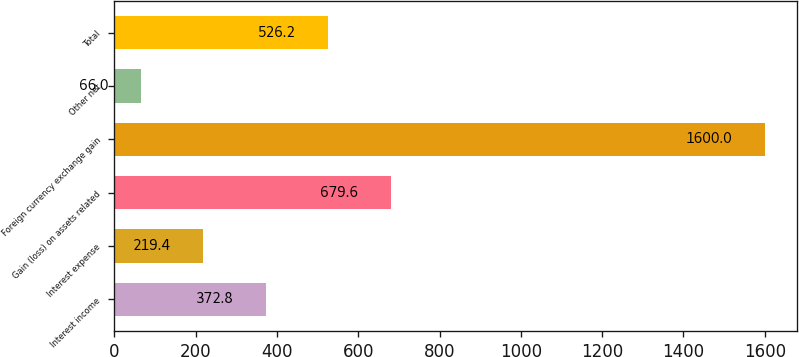<chart> <loc_0><loc_0><loc_500><loc_500><bar_chart><fcel>Interest income<fcel>Interest expense<fcel>Gain (loss) on assets related<fcel>Foreign currency exchange gain<fcel>Other net<fcel>Total<nl><fcel>372.8<fcel>219.4<fcel>679.6<fcel>1600<fcel>66<fcel>526.2<nl></chart> 